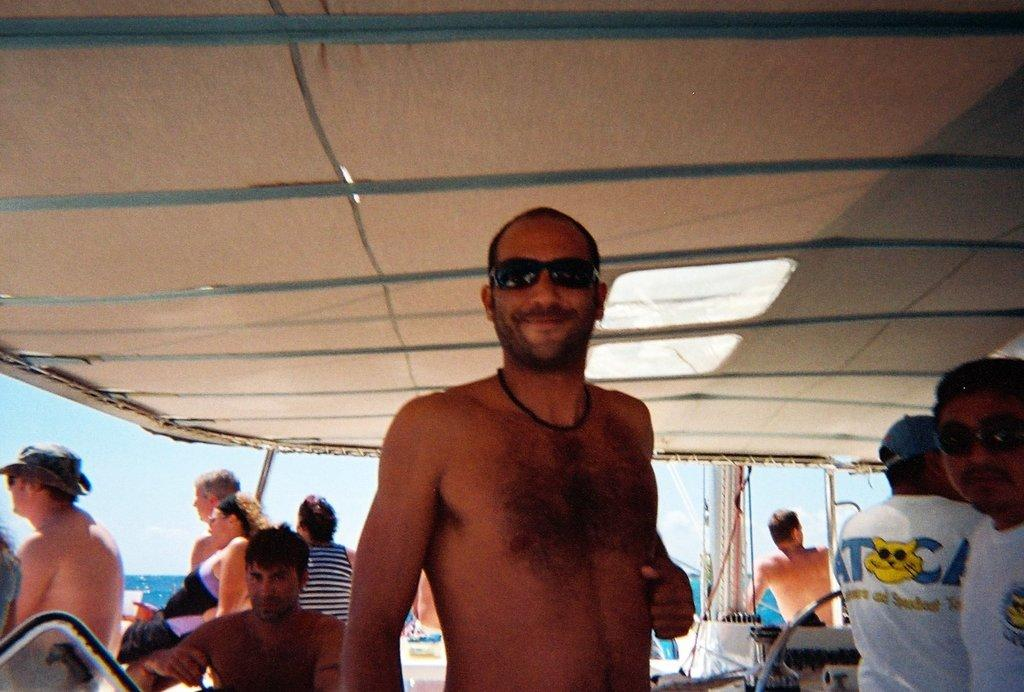Where are the people located in the image? The people are standing under a roof. What can be seen in the background of the image? There is a large water body visible in the background, along with poles. How would you describe the sky in the image? The sky is visible and appears cloudy. How many rings are visible on the faucet in the image? There is no faucet present in the image, so it is not possible to determine the number of rings. 